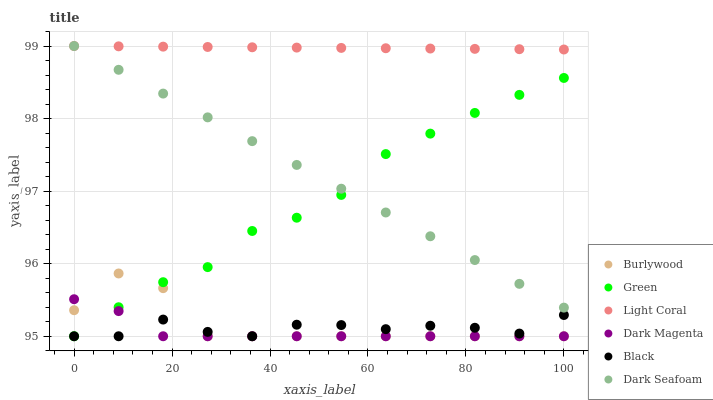Does Dark Magenta have the minimum area under the curve?
Answer yes or no. Yes. Does Light Coral have the maximum area under the curve?
Answer yes or no. Yes. Does Burlywood have the minimum area under the curve?
Answer yes or no. No. Does Burlywood have the maximum area under the curve?
Answer yes or no. No. Is Light Coral the smoothest?
Answer yes or no. Yes. Is Burlywood the roughest?
Answer yes or no. Yes. Is Burlywood the smoothest?
Answer yes or no. No. Is Light Coral the roughest?
Answer yes or no. No. Does Dark Magenta have the lowest value?
Answer yes or no. Yes. Does Light Coral have the lowest value?
Answer yes or no. No. Does Dark Seafoam have the highest value?
Answer yes or no. Yes. Does Burlywood have the highest value?
Answer yes or no. No. Is Dark Magenta less than Dark Seafoam?
Answer yes or no. Yes. Is Light Coral greater than Burlywood?
Answer yes or no. Yes. Does Light Coral intersect Dark Seafoam?
Answer yes or no. Yes. Is Light Coral less than Dark Seafoam?
Answer yes or no. No. Is Light Coral greater than Dark Seafoam?
Answer yes or no. No. Does Dark Magenta intersect Dark Seafoam?
Answer yes or no. No. 